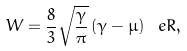Convert formula to latex. <formula><loc_0><loc_0><loc_500><loc_500>W = \frac { 8 } { 3 } \sqrt { \frac { \gamma } { \pi } } \, ( \gamma - \mu ) \, \ e R ,</formula> 